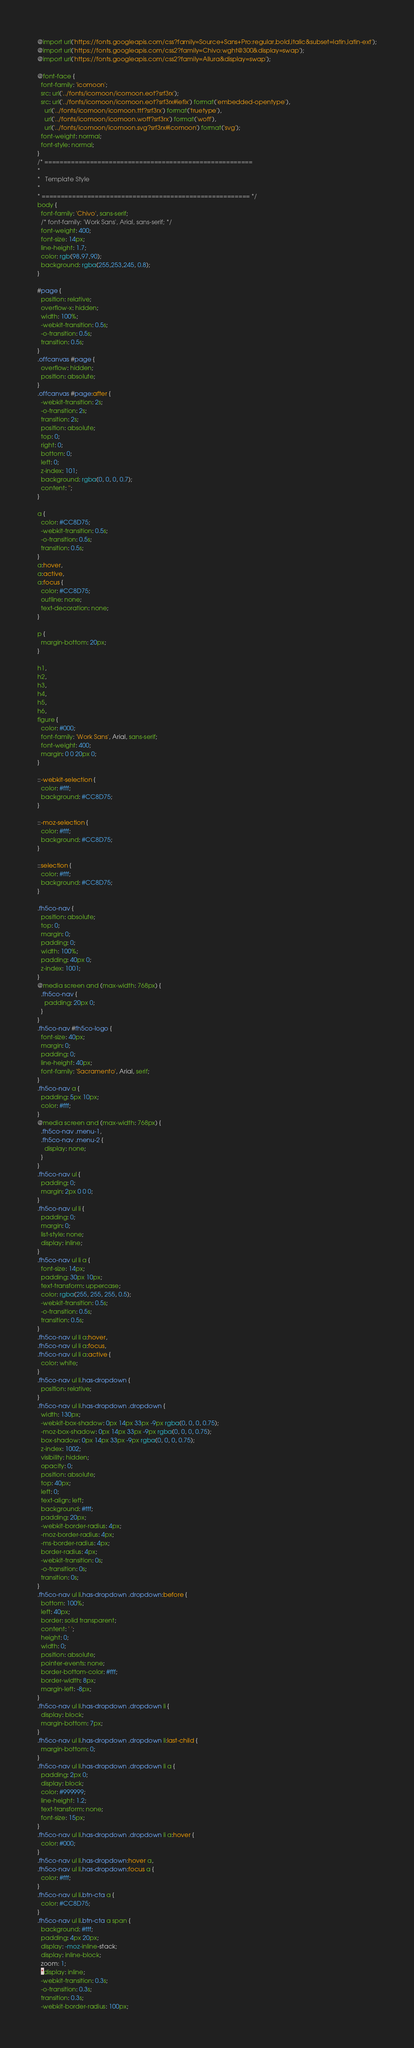<code> <loc_0><loc_0><loc_500><loc_500><_CSS_>@import url('https://fonts.googleapis.com/css?family=Source+Sans+Pro:regular,bold,italic&subset=latin,latin-ext');
@import url('https://fonts.googleapis.com/css2?family=Chivo:wght@300&display=swap');
@import url('https://fonts.googleapis.com/css2?family=Allura&display=swap');

@font-face {
  font-family: 'icomoon';
  src: url('../fonts/icomoon/icomoon.eot?srf3rx');
  src: url('../fonts/icomoon/icomoon.eot?srf3rx#iefix') format('embedded-opentype'),
    url('../fonts/icomoon/icomoon.ttf?srf3rx') format('truetype'),
    url('../fonts/icomoon/icomoon.woff?srf3rx') format('woff'),
    url('../fonts/icomoon/icomoon.svg?srf3rx#icomoon') format('svg');
  font-weight: normal;
  font-style: normal;
}
/* =======================================================
*
* 	Template Style 
*
* ======================================================= */
body {
  font-family: 'Chivo', sans-serif;
  /* font-family: 'Work Sans', Arial, sans-serif; */
  font-weight: 400;
  font-size: 14px;
  line-height: 1.7;
  color: rgb(98,97,90);
  background: rgba(255,253,245, 0.8);
}

#page {
  position: relative;
  overflow-x: hidden;
  width: 100%;
  -webkit-transition: 0.5s;
  -o-transition: 0.5s;
  transition: 0.5s;
}
.offcanvas #page {
  overflow: hidden;
  position: absolute;
}
.offcanvas #page:after {
  -webkit-transition: 2s;
  -o-transition: 2s;
  transition: 2s;
  position: absolute;
  top: 0;
  right: 0;
  bottom: 0;
  left: 0;
  z-index: 101;
  background: rgba(0, 0, 0, 0.7);
  content: '';
}

a {
  color: #CC8D75;
  -webkit-transition: 0.5s;
  -o-transition: 0.5s;
  transition: 0.5s;
}
a:hover,
a:active,
a:focus {
  color: #CC8D75;
  outline: none;
  text-decoration: none;
}

p {
  margin-bottom: 20px;
}

h1,
h2,
h3,
h4,
h5,
h6,
figure {
  color: #000;
  font-family: 'Work Sans', Arial, sans-serif;
  font-weight: 400;
  margin: 0 0 20px 0;
}

::-webkit-selection {
  color: #fff;
  background: #CC8D75;
}

::-moz-selection {
  color: #fff;
  background: #CC8D75;
}

::selection {
  color: #fff;
  background: #CC8D75;
}

.fh5co-nav {
  position: absolute;
  top: 0;
  margin: 0;
  padding: 0;
  width: 100%;
  padding: 40px 0;
  z-index: 1001;
}
@media screen and (max-width: 768px) {
  .fh5co-nav {
    padding: 20px 0;
  }
}
.fh5co-nav #fh5co-logo {
  font-size: 40px;
  margin: 0;
  padding: 0;
  line-height: 40px;
  font-family: 'Sacramento', Arial, serif;
}
.fh5co-nav a {
  padding: 5px 10px;
  color: #fff;
}
@media screen and (max-width: 768px) {
  .fh5co-nav .menu-1,
  .fh5co-nav .menu-2 {
    display: none;
  }
}
.fh5co-nav ul {
  padding: 0;
  margin: 2px 0 0 0;
}
.fh5co-nav ul li {
  padding: 0;
  margin: 0;
  list-style: none;
  display: inline;
}
.fh5co-nav ul li a {
  font-size: 14px;
  padding: 30px 10px;
  text-transform: uppercase;
  color: rgba(255, 255, 255, 0.5);
  -webkit-transition: 0.5s;
  -o-transition: 0.5s;
  transition: 0.5s;
}
.fh5co-nav ul li a:hover,
.fh5co-nav ul li a:focus,
.fh5co-nav ul li a:active {
  color: white;
}
.fh5co-nav ul li.has-dropdown {
  position: relative;
}
.fh5co-nav ul li.has-dropdown .dropdown {
  width: 130px;
  -webkit-box-shadow: 0px 14px 33px -9px rgba(0, 0, 0, 0.75);
  -moz-box-shadow: 0px 14px 33px -9px rgba(0, 0, 0, 0.75);
  box-shadow: 0px 14px 33px -9px rgba(0, 0, 0, 0.75);
  z-index: 1002;
  visibility: hidden;
  opacity: 0;
  position: absolute;
  top: 40px;
  left: 0;
  text-align: left;
  background: #fff;
  padding: 20px;
  -webkit-border-radius: 4px;
  -moz-border-radius: 4px;
  -ms-border-radius: 4px;
  border-radius: 4px;
  -webkit-transition: 0s;
  -o-transition: 0s;
  transition: 0s;
}
.fh5co-nav ul li.has-dropdown .dropdown:before {
  bottom: 100%;
  left: 40px;
  border: solid transparent;
  content: ' ';
  height: 0;
  width: 0;
  position: absolute;
  pointer-events: none;
  border-bottom-color: #fff;
  border-width: 8px;
  margin-left: -8px;
}
.fh5co-nav ul li.has-dropdown .dropdown li {
  display: block;
  margin-bottom: 7px;
}
.fh5co-nav ul li.has-dropdown .dropdown li:last-child {
  margin-bottom: 0;
}
.fh5co-nav ul li.has-dropdown .dropdown li a {
  padding: 2px 0;
  display: block;
  color: #999999;
  line-height: 1.2;
  text-transform: none;
  font-size: 15px;
}
.fh5co-nav ul li.has-dropdown .dropdown li a:hover {
  color: #000;
}
.fh5co-nav ul li.has-dropdown:hover a,
.fh5co-nav ul li.has-dropdown:focus a {
  color: #fff;
}
.fh5co-nav ul li.btn-cta a {
  color: #CC8D75;
}
.fh5co-nav ul li.btn-cta a span {
  background: #fff;
  padding: 4px 20px;
  display: -moz-inline-stack;
  display: inline-block;
  zoom: 1;
  *display: inline;
  -webkit-transition: 0.3s;
  -o-transition: 0.3s;
  transition: 0.3s;
  -webkit-border-radius: 100px;</code> 